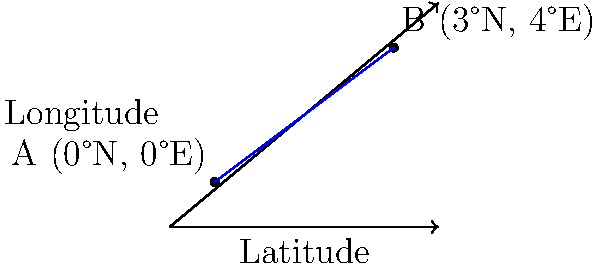Your mom is planning a trip and wants to know the distance between two cities on her map. City A is located at 0°N, 0°E, and City B is at 3°N, 4°E. If each degree on the map represents 111 km on Earth's surface, how far apart are these two cities? Let's approach this step-by-step:

1) First, we need to understand that the cities' positions form a right triangle on the map, where:
   - The difference in longitude is the base (4°E - 0°E = 4°)
   - The difference in latitude is the height (3°N - 0°N = 3°)

2) We can use the Pythagorean theorem to find the distance:
   $d^2 = x^2 + y^2$, where d is the distance, x is the longitude difference, and y is the latitude difference.

3) Plugging in our values:
   $d^2 = 4^2 + 3^2 = 16 + 9 = 25$

4) Taking the square root of both sides:
   $d = \sqrt{25} = 5°$

5) Now, we know the angular distance is 5°. We need to convert this to kilometers.

6) Given: 1° = 111 km

7) Therefore, the distance in km is:
   $5° \times 111 \text{ km/°} = 555 \text{ km}$

Thus, the two cities are approximately 555 km apart.
Answer: 555 km 